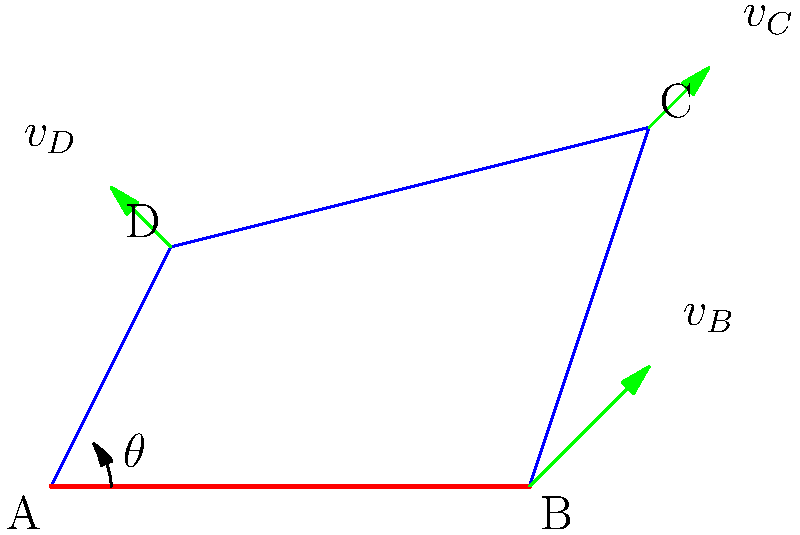In the four-bar linkage mechanism shown, link AB is the input crank rotating at a constant angular velocity $\omega$ of 10 rad/s. At the instant when the crank angle $\theta$ is 45°, determine the velocity of point C in m/s. Assume AB = 4 m, BC = 3 m, CD = 5 m, and AD = 3 m. To solve this problem, we'll use the relative velocity method:

1) First, let's calculate the velocity of point B:
   $v_B = \omega \cdot AB = 10 \cdot 4 = 40$ m/s

2) The direction of $v_B$ is perpendicular to AB, at 135° from the horizontal.

3) Now, we can use the velocity polygon method. We know that:
   $v_C = v_B + v_{C/B}$

4) $v_{C/B}$ is perpendicular to BC, but its magnitude is unknown.

5) $v_C$ must be perpendicular to DC, as D is fixed.

6) We can now draw a velocity polygon:
   - Draw $v_B$ (40 m/s at 135°)
   - From the tip of $v_B$, draw a line perpendicular to BC
   - From the origin, draw a line perpendicular to DC
   - The intersection of these lines gives us $v_C$

7) Measuring this velocity vector (or calculating it trigonometrically), we find:
   $v_C \approx 30$ m/s

8) The direction of $v_C$ is perpendicular to DC, pointing upwards and slightly to the left.

This method, known as the velocity polygon or relative velocity method, is a graphical solution that can be very useful in analyzing four-bar linkages.
Answer: $v_C \approx 30$ m/s 